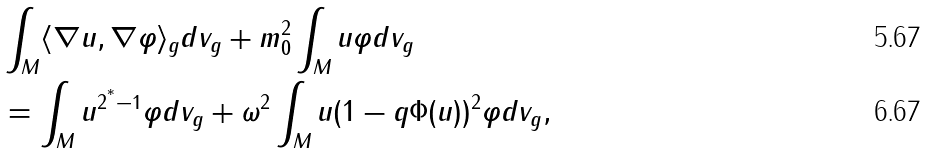<formula> <loc_0><loc_0><loc_500><loc_500>& \int _ { M } \langle \nabla u , \nabla \varphi \rangle _ { g } d v _ { g } + m _ { 0 } ^ { 2 } \int _ { M } u \varphi d v _ { g } \\ & = \int _ { M } u ^ { 2 ^ { ^ { * } } - 1 } \varphi d v _ { g } + \omega ^ { 2 } \int _ { M } u ( 1 - q \Phi ( u ) ) ^ { 2 } \varphi d v _ { g } ,</formula> 